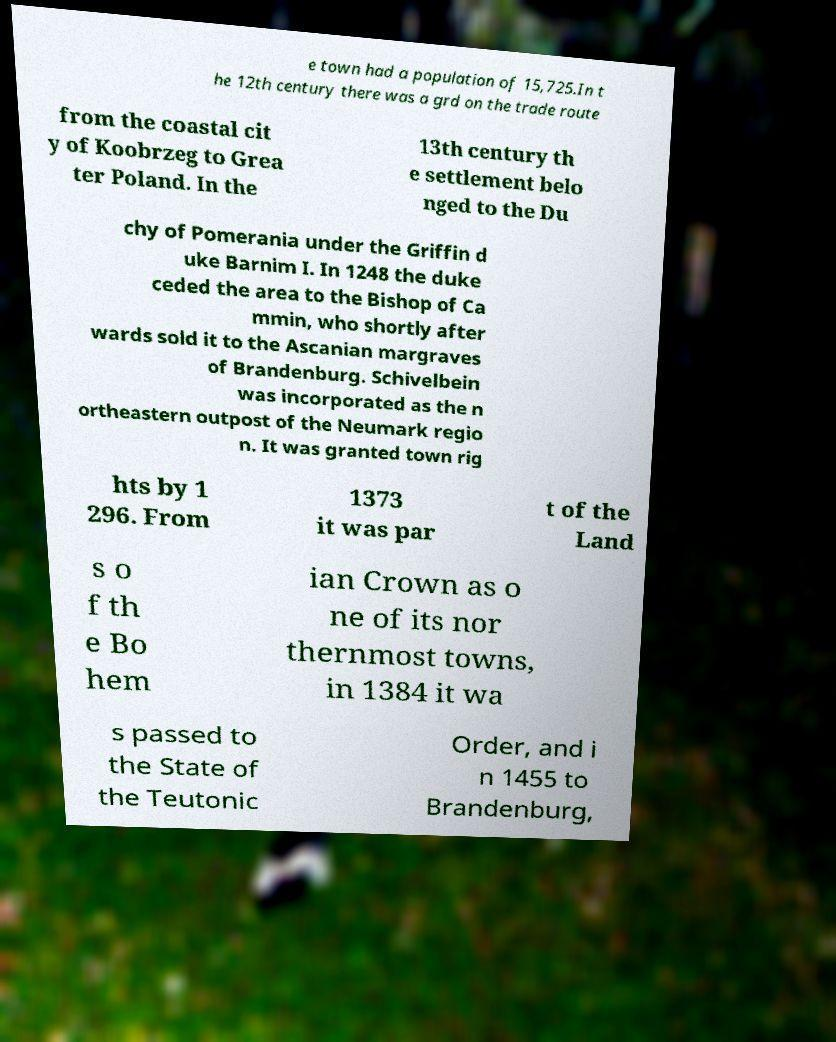Can you accurately transcribe the text from the provided image for me? e town had a population of 15,725.In t he 12th century there was a grd on the trade route from the coastal cit y of Koobrzeg to Grea ter Poland. In the 13th century th e settlement belo nged to the Du chy of Pomerania under the Griffin d uke Barnim I. In 1248 the duke ceded the area to the Bishop of Ca mmin, who shortly after wards sold it to the Ascanian margraves of Brandenburg. Schivelbein was incorporated as the n ortheastern outpost of the Neumark regio n. It was granted town rig hts by 1 296. From 1373 it was par t of the Land s o f th e Bo hem ian Crown as o ne of its nor thernmost towns, in 1384 it wa s passed to the State of the Teutonic Order, and i n 1455 to Brandenburg, 